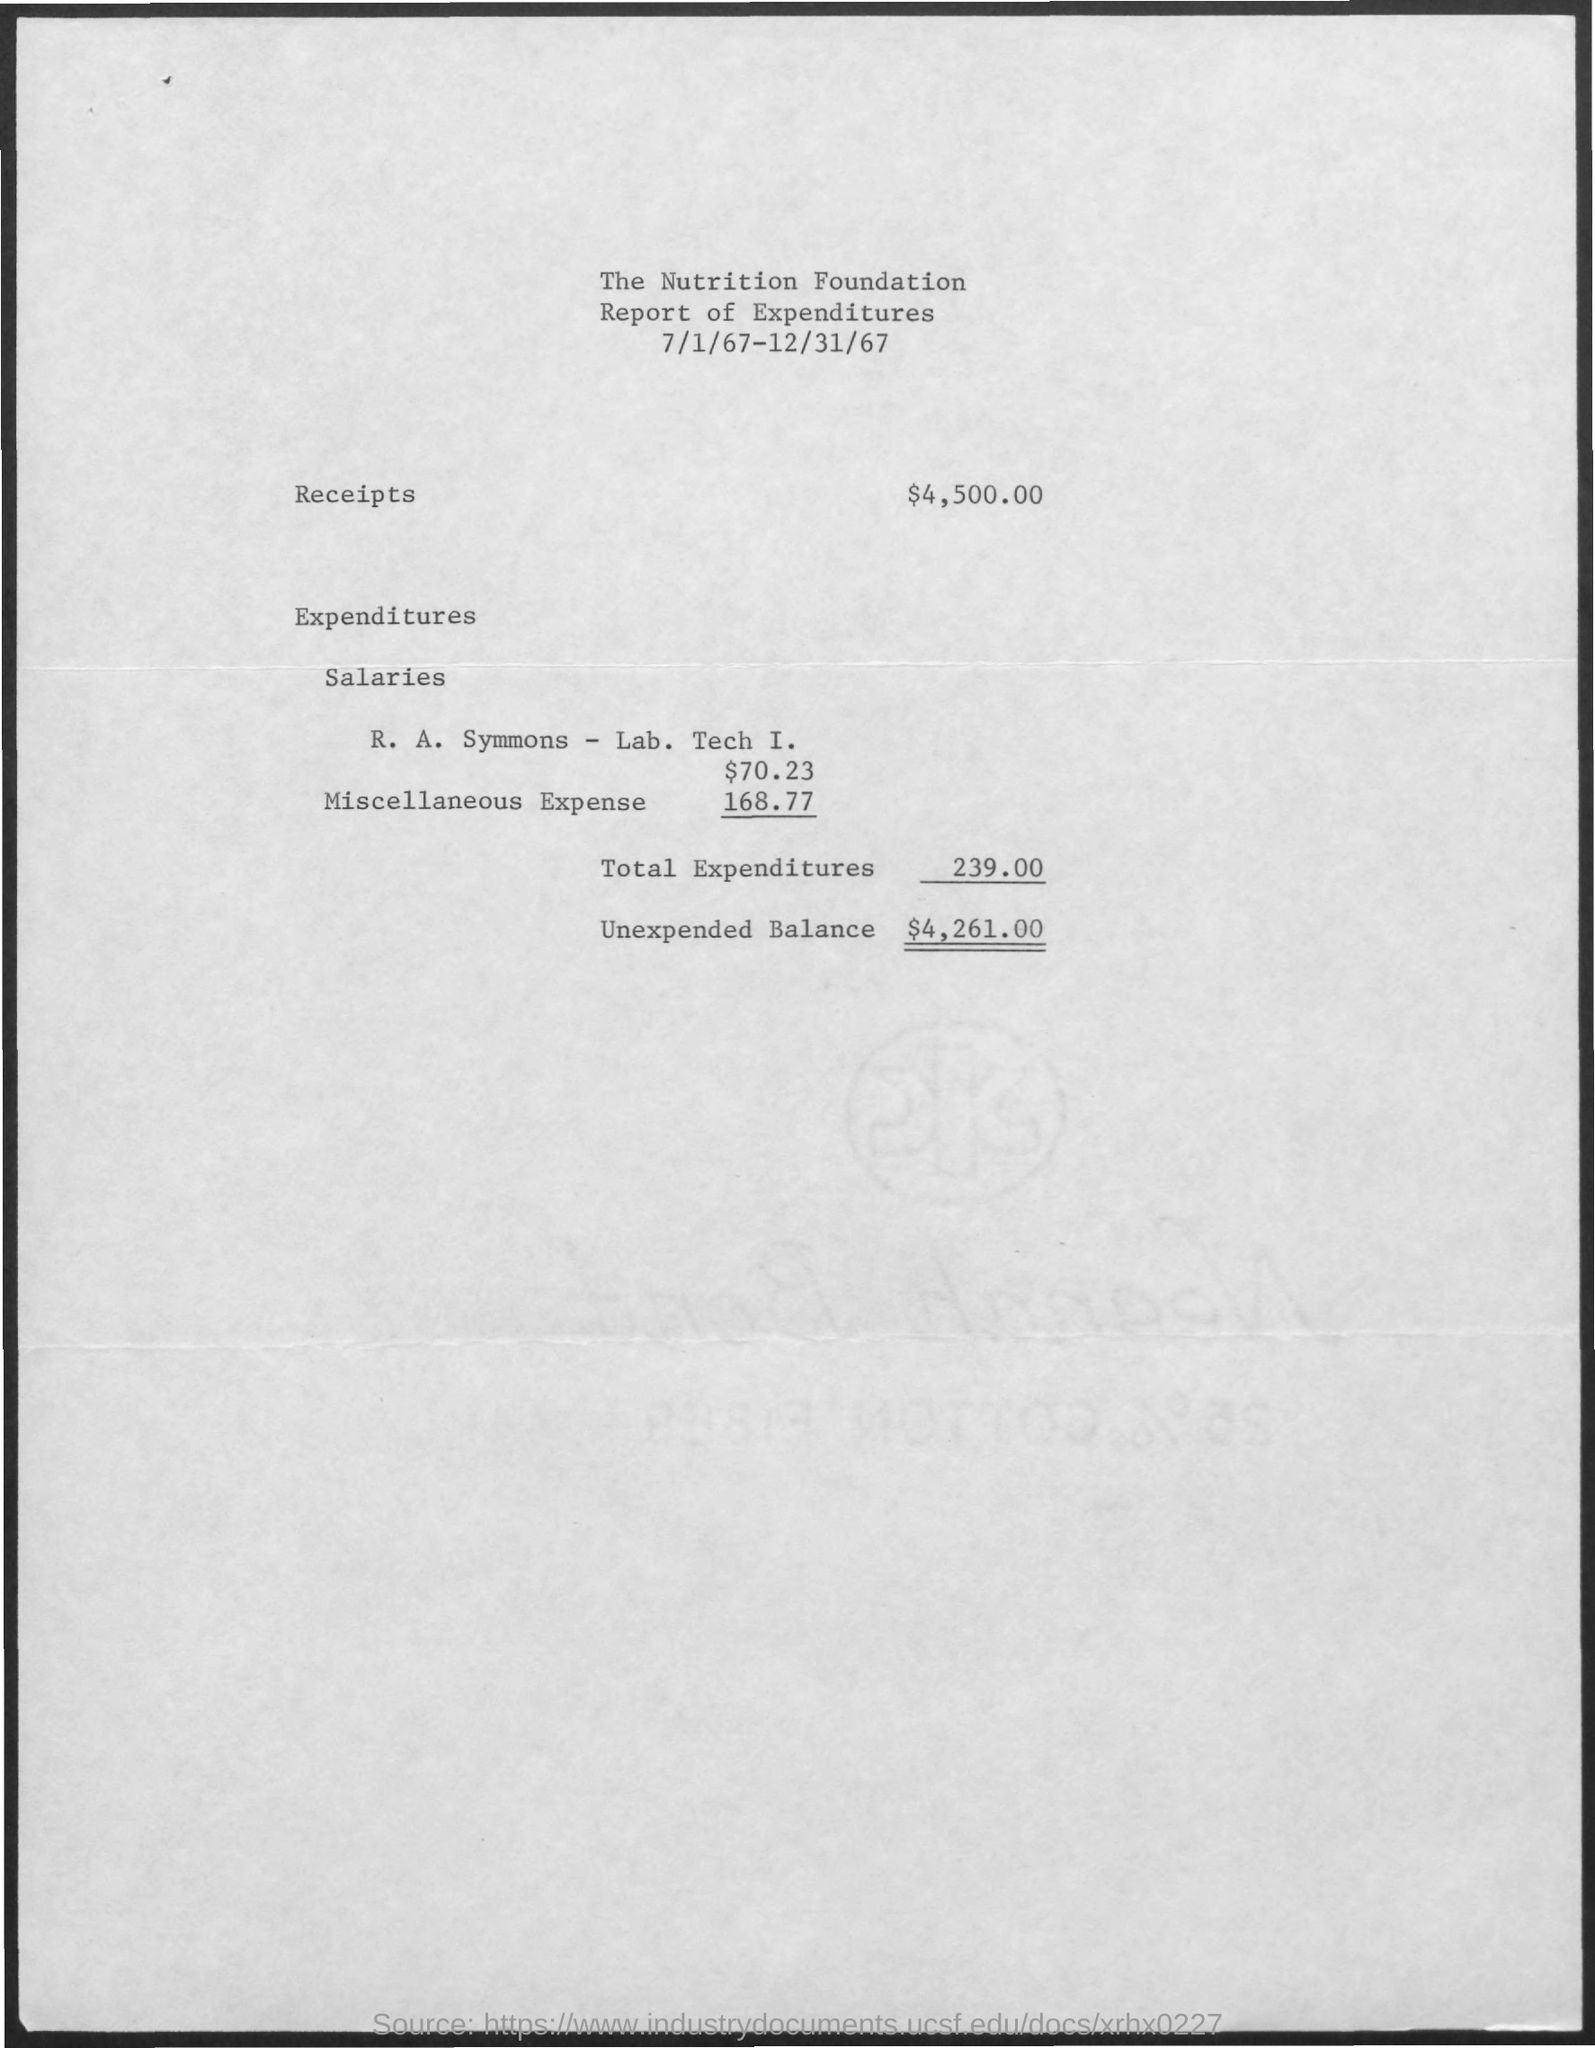List a handful of essential elements in this visual. The title of the document is the Nutrition Foundation Report of Expenditures. The document is dated from July 1, 1967 to December 31, 1967. The total expenditures amount to 239.00. 